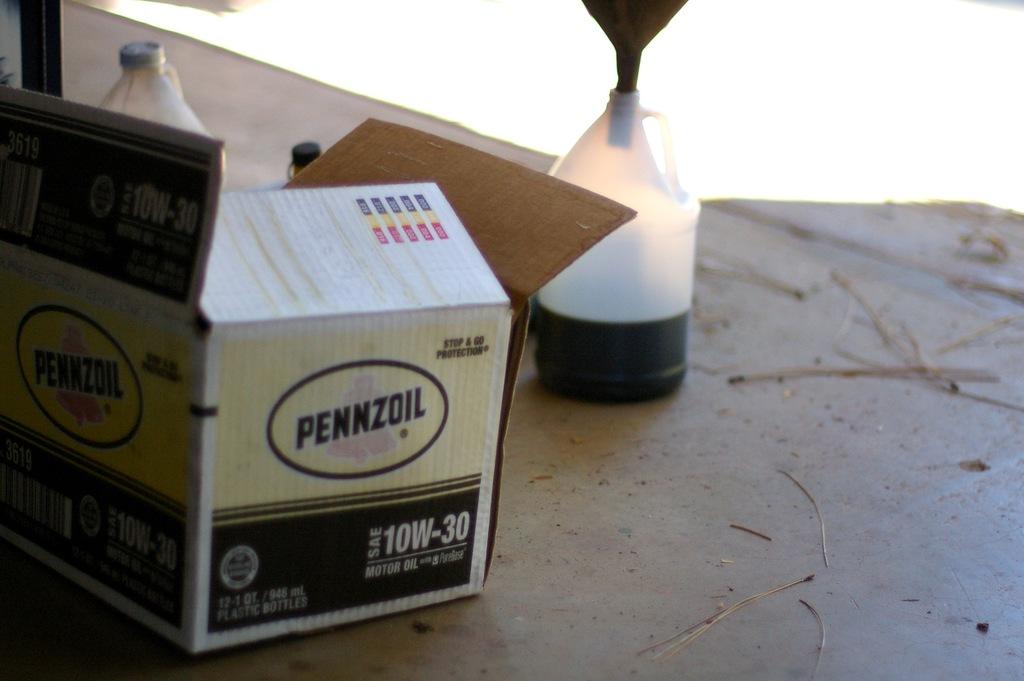What kind of brand of oil is mentioned?
Provide a succinct answer. Pennzoil. What does it say in the box?
Your answer should be compact. Pennzoil. 